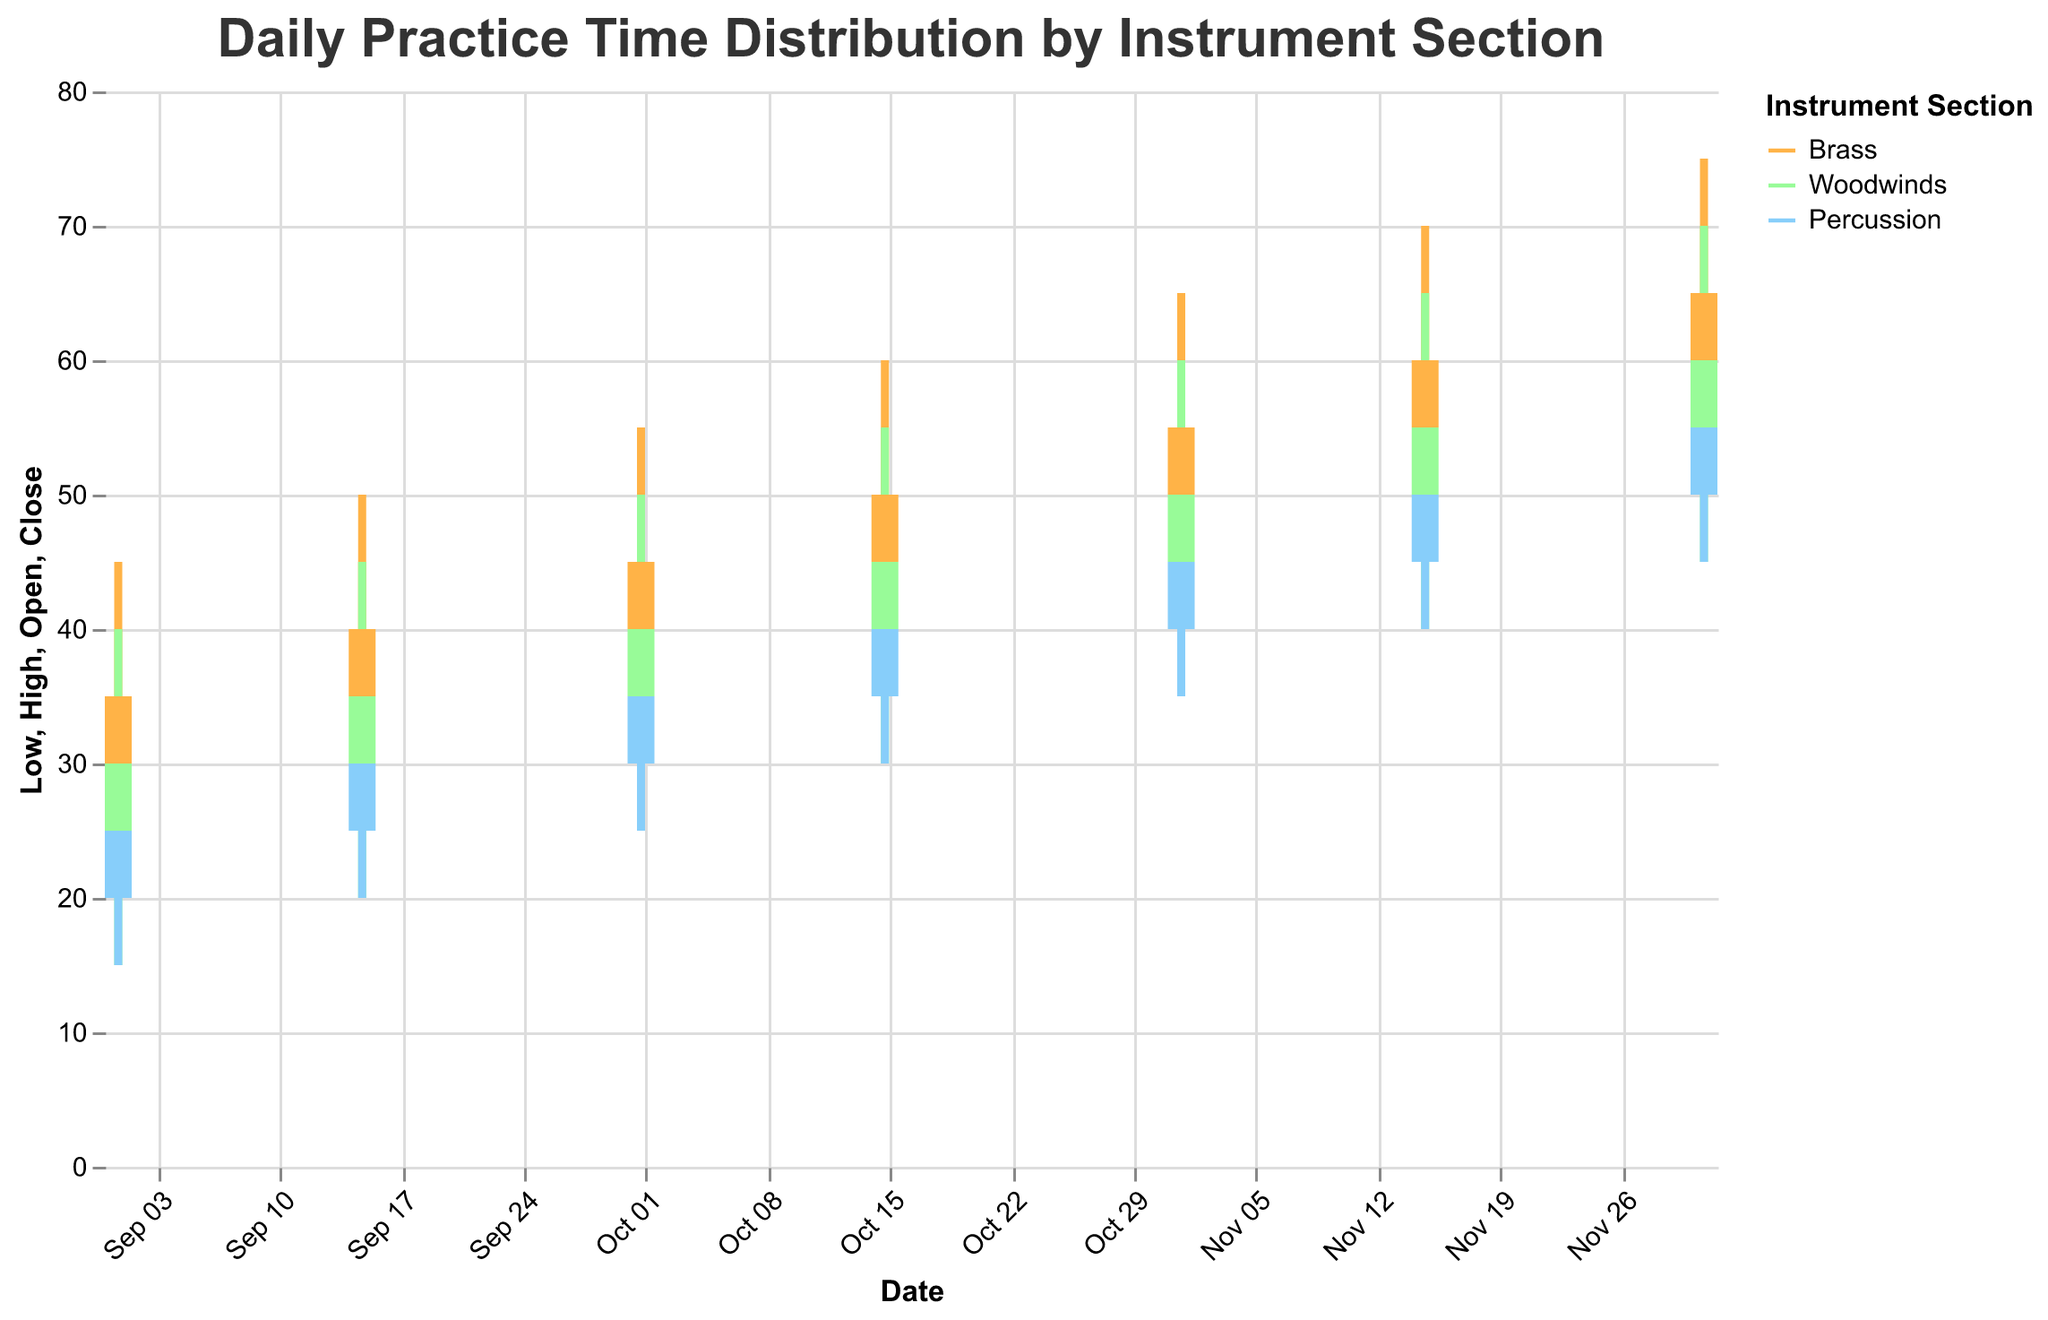What is the title of the figure? The title is usually displayed at the top of the figure. In this case, it provides a summary of what the chart represents.
Answer: Daily Practice Time Distribution by Instrument Section How many instrument sections are represented in the figure? By observing the color legend, we can identify the three different instrument sections displayed.
Answer: Three (Brass, Woodwinds, Percussion) Which instrument section has the highest "High" value on December 1, 2023? Check the height (y-axis) of the "High" value bars for each section on December 1. Look for the tallest bar which corresponds to the highest "High" value.
Answer: Brass Which date shows the largest range in practice times for the Brass section? Calculate the range (High - Low) for the Brass section on each date. Compare these ranges to find the date with the largest value.
Answer: December 1, 2023 (Range = 75 - 50 = 25) Did the practice time for the Woodwinds section close higher or lower on November 15 compared to November 1? Compare the "Close" values for Woodwinds on November 1 and November 15.
Answer: Higher (55 on November 15 vs. 50 on November 1) Which instrument section shows a consistent increase in all their "Close" values from September 1 to December 1? Examine the "Close" values for each section over the given dates to check for a consistent increase without any decrease.
Answer: Brass What is the average "Open" practice time for the Percussion section across all dates? Sum the "Open" values for Percussion and divide by the number of data points (6).
Answer: (20 + 25 + 30 + 35 + 40 + 45) / 6 = 32.5 On which date do all sections show an "Open" value of at least 50 minutes? Check the "Open" values for each section on each date and identify the date where all sections have "Open" values 50 or higher.
Answer: December 1, 2023 Which section has the smallest range of practice times on October 15, 2023? Calculate the range (High - Low) for each section on October 15 and compare them.
Answer: Woodwinds (Range = 25) 